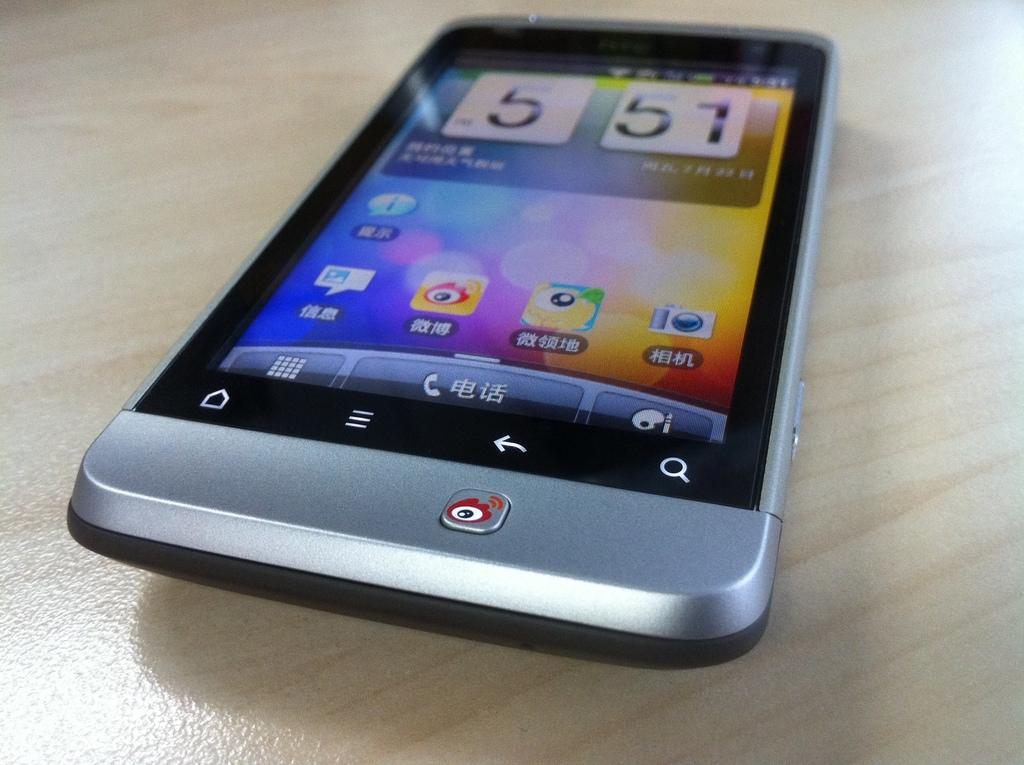What type of device is in the image? There is a touch screen mobile phone in the image. Where is the mobile phone located? The mobile phone is on a table. What can be seen on the mobile phone screen? There are apps visible on the mobile phone screen, as well as the date and time. What type of clam is sitting on the table next to the mobile phone? There is no clam present in the image; it only features a touch screen mobile phone on a table. 